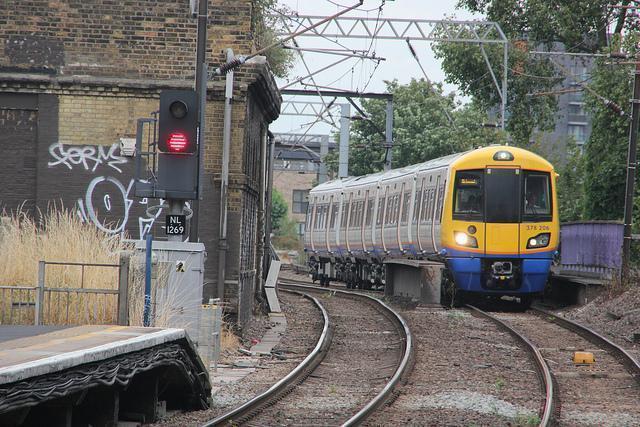This train is moved by what energy?
Indicate the correct response by choosing from the four available options to answer the question.
Options: Magnetic force, coal, gas, electricity. Electricity. 